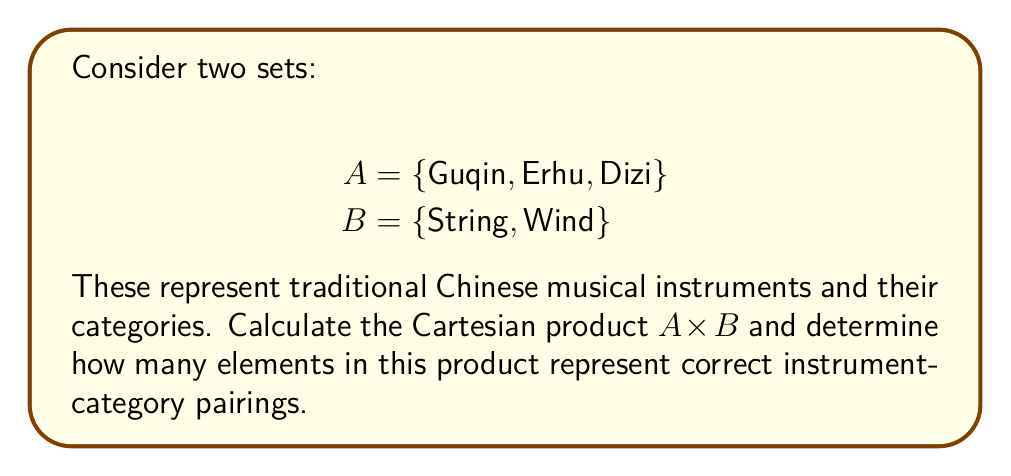Could you help me with this problem? To solve this problem, we'll follow these steps:

1) First, let's recall the definition of Cartesian product:
   For sets A and B, the Cartesian product A × B is the set of all ordered pairs (a, b) where a ∈ A and b ∈ B.

2) Let's calculate A × B:
   A × B = {(Guqin, String), (Guqin, Wind), (Erhu, String), (Erhu, Wind), (Dizi, String), (Dizi, Wind)}

3) Now, we need to determine which of these pairings are correct:
   - Guqin is a string instrument
   - Erhu is a string instrument
   - Dizi is a wind instrument

4) Counting the correct pairings:
   (Guqin, String), (Erhu, String), and (Dizi, Wind) are correct.

5) Therefore, out of the 6 elements in A × B, 3 represent correct instrument-category pairings.

This problem demonstrates how Cartesian products can be used to systematically pair elements from two sets, which is useful in organizing and categorizing cultural artifacts like traditional musical instruments.
Answer: 3 elements of A × B represent correct instrument-category pairings. 